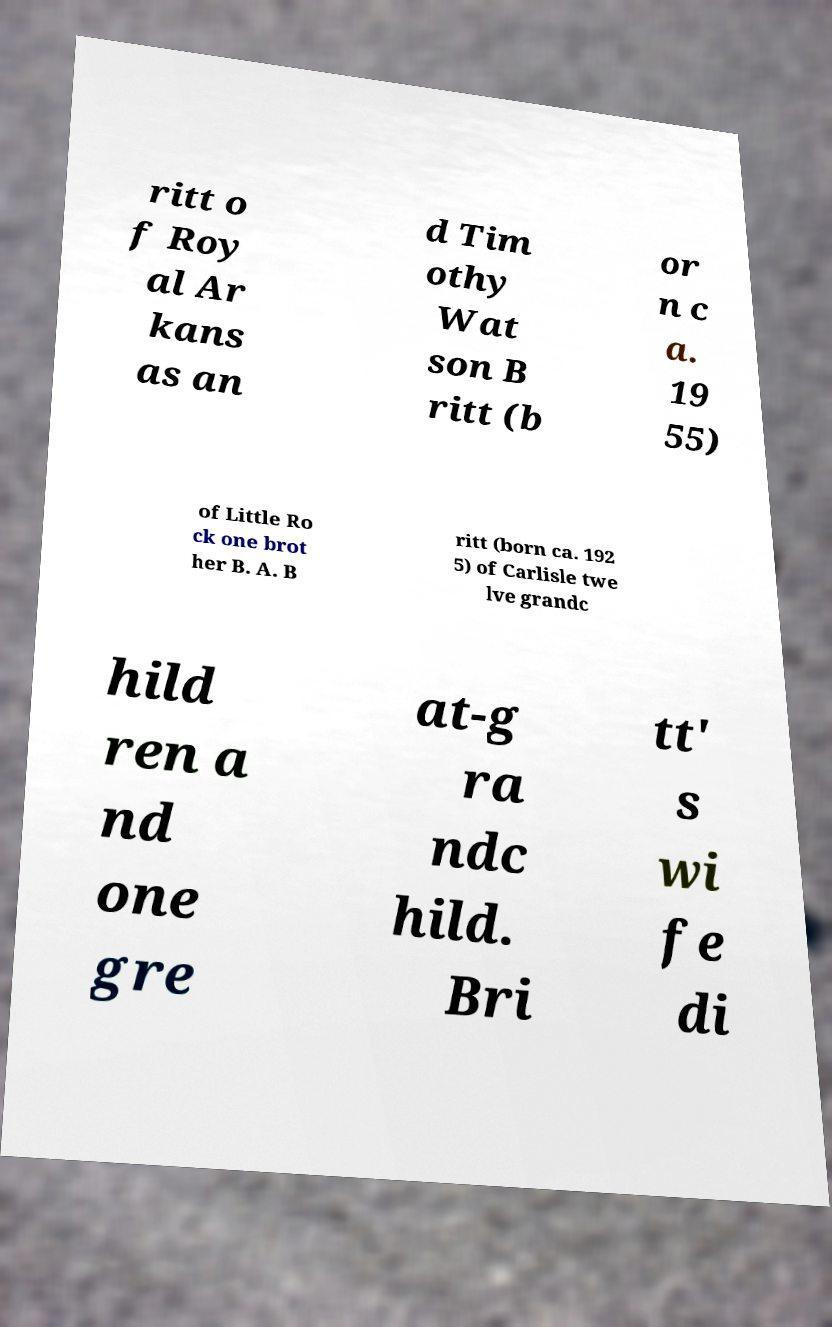What messages or text are displayed in this image? I need them in a readable, typed format. ritt o f Roy al Ar kans as an d Tim othy Wat son B ritt (b or n c a. 19 55) of Little Ro ck one brot her B. A. B ritt (born ca. 192 5) of Carlisle twe lve grandc hild ren a nd one gre at-g ra ndc hild. Bri tt' s wi fe di 